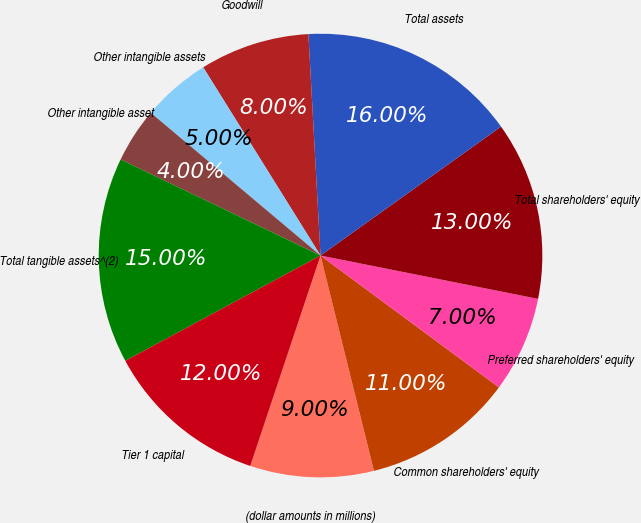Convert chart. <chart><loc_0><loc_0><loc_500><loc_500><pie_chart><fcel>(dollar amounts in millions)<fcel>Common shareholders' equity<fcel>Preferred shareholders' equity<fcel>Total shareholders' equity<fcel>Total assets<fcel>Goodwill<fcel>Other intangible assets<fcel>Other intangible asset<fcel>Total tangible assets^(2)<fcel>Tier 1 capital<nl><fcel>9.0%<fcel>11.0%<fcel>7.0%<fcel>13.0%<fcel>16.0%<fcel>8.0%<fcel>5.0%<fcel>4.0%<fcel>15.0%<fcel>12.0%<nl></chart> 